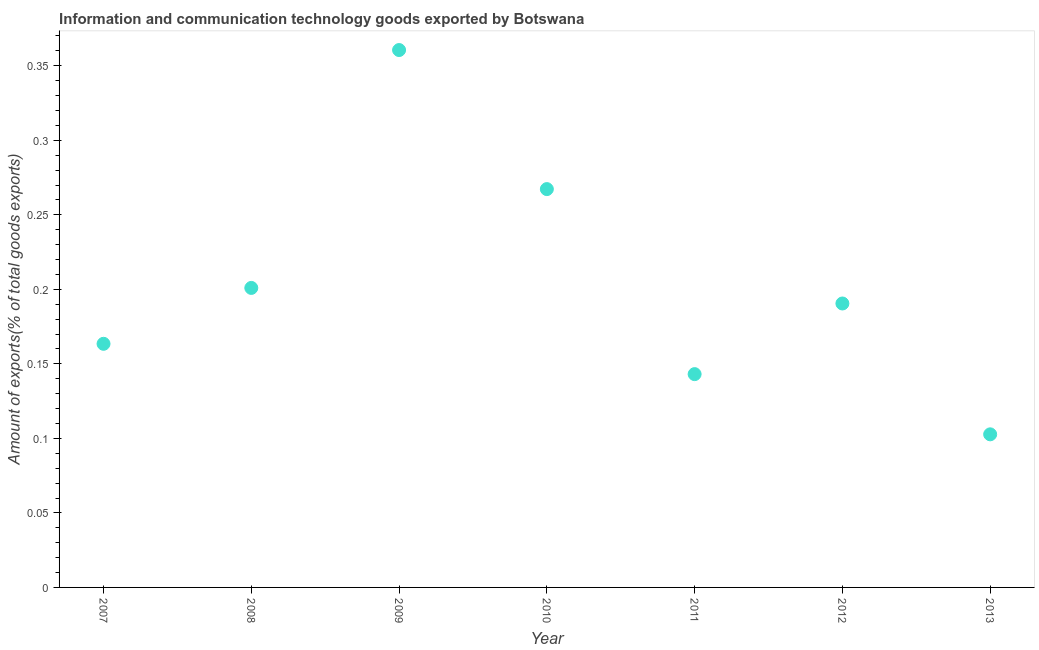What is the amount of ict goods exports in 2008?
Give a very brief answer. 0.2. Across all years, what is the maximum amount of ict goods exports?
Provide a succinct answer. 0.36. Across all years, what is the minimum amount of ict goods exports?
Your answer should be compact. 0.1. What is the sum of the amount of ict goods exports?
Offer a terse response. 1.43. What is the difference between the amount of ict goods exports in 2009 and 2011?
Give a very brief answer. 0.22. What is the average amount of ict goods exports per year?
Your answer should be compact. 0.2. What is the median amount of ict goods exports?
Your response must be concise. 0.19. Do a majority of the years between 2009 and 2007 (inclusive) have amount of ict goods exports greater than 0.22 %?
Give a very brief answer. No. What is the ratio of the amount of ict goods exports in 2010 to that in 2012?
Your response must be concise. 1.4. Is the amount of ict goods exports in 2007 less than that in 2012?
Give a very brief answer. Yes. What is the difference between the highest and the second highest amount of ict goods exports?
Ensure brevity in your answer.  0.09. Is the sum of the amount of ict goods exports in 2008 and 2011 greater than the maximum amount of ict goods exports across all years?
Your answer should be compact. No. What is the difference between the highest and the lowest amount of ict goods exports?
Your answer should be very brief. 0.26. Does the amount of ict goods exports monotonically increase over the years?
Offer a very short reply. No. How many years are there in the graph?
Your response must be concise. 7. Are the values on the major ticks of Y-axis written in scientific E-notation?
Give a very brief answer. No. What is the title of the graph?
Provide a short and direct response. Information and communication technology goods exported by Botswana. What is the label or title of the Y-axis?
Offer a very short reply. Amount of exports(% of total goods exports). What is the Amount of exports(% of total goods exports) in 2007?
Offer a terse response. 0.16. What is the Amount of exports(% of total goods exports) in 2008?
Offer a very short reply. 0.2. What is the Amount of exports(% of total goods exports) in 2009?
Provide a succinct answer. 0.36. What is the Amount of exports(% of total goods exports) in 2010?
Your answer should be very brief. 0.27. What is the Amount of exports(% of total goods exports) in 2011?
Provide a short and direct response. 0.14. What is the Amount of exports(% of total goods exports) in 2012?
Ensure brevity in your answer.  0.19. What is the Amount of exports(% of total goods exports) in 2013?
Keep it short and to the point. 0.1. What is the difference between the Amount of exports(% of total goods exports) in 2007 and 2008?
Provide a short and direct response. -0.04. What is the difference between the Amount of exports(% of total goods exports) in 2007 and 2009?
Make the answer very short. -0.2. What is the difference between the Amount of exports(% of total goods exports) in 2007 and 2010?
Offer a very short reply. -0.1. What is the difference between the Amount of exports(% of total goods exports) in 2007 and 2011?
Provide a short and direct response. 0.02. What is the difference between the Amount of exports(% of total goods exports) in 2007 and 2012?
Offer a very short reply. -0.03. What is the difference between the Amount of exports(% of total goods exports) in 2007 and 2013?
Your answer should be very brief. 0.06. What is the difference between the Amount of exports(% of total goods exports) in 2008 and 2009?
Provide a succinct answer. -0.16. What is the difference between the Amount of exports(% of total goods exports) in 2008 and 2010?
Offer a very short reply. -0.07. What is the difference between the Amount of exports(% of total goods exports) in 2008 and 2011?
Ensure brevity in your answer.  0.06. What is the difference between the Amount of exports(% of total goods exports) in 2008 and 2012?
Your response must be concise. 0.01. What is the difference between the Amount of exports(% of total goods exports) in 2008 and 2013?
Provide a short and direct response. 0.1. What is the difference between the Amount of exports(% of total goods exports) in 2009 and 2010?
Your answer should be very brief. 0.09. What is the difference between the Amount of exports(% of total goods exports) in 2009 and 2011?
Provide a succinct answer. 0.22. What is the difference between the Amount of exports(% of total goods exports) in 2009 and 2012?
Provide a short and direct response. 0.17. What is the difference between the Amount of exports(% of total goods exports) in 2009 and 2013?
Your answer should be very brief. 0.26. What is the difference between the Amount of exports(% of total goods exports) in 2010 and 2011?
Your answer should be compact. 0.12. What is the difference between the Amount of exports(% of total goods exports) in 2010 and 2012?
Make the answer very short. 0.08. What is the difference between the Amount of exports(% of total goods exports) in 2010 and 2013?
Provide a short and direct response. 0.16. What is the difference between the Amount of exports(% of total goods exports) in 2011 and 2012?
Offer a terse response. -0.05. What is the difference between the Amount of exports(% of total goods exports) in 2011 and 2013?
Offer a very short reply. 0.04. What is the difference between the Amount of exports(% of total goods exports) in 2012 and 2013?
Your answer should be very brief. 0.09. What is the ratio of the Amount of exports(% of total goods exports) in 2007 to that in 2008?
Your answer should be compact. 0.81. What is the ratio of the Amount of exports(% of total goods exports) in 2007 to that in 2009?
Your response must be concise. 0.45. What is the ratio of the Amount of exports(% of total goods exports) in 2007 to that in 2010?
Your answer should be compact. 0.61. What is the ratio of the Amount of exports(% of total goods exports) in 2007 to that in 2011?
Make the answer very short. 1.14. What is the ratio of the Amount of exports(% of total goods exports) in 2007 to that in 2012?
Provide a succinct answer. 0.86. What is the ratio of the Amount of exports(% of total goods exports) in 2007 to that in 2013?
Make the answer very short. 1.59. What is the ratio of the Amount of exports(% of total goods exports) in 2008 to that in 2009?
Make the answer very short. 0.56. What is the ratio of the Amount of exports(% of total goods exports) in 2008 to that in 2010?
Offer a very short reply. 0.75. What is the ratio of the Amount of exports(% of total goods exports) in 2008 to that in 2011?
Make the answer very short. 1.4. What is the ratio of the Amount of exports(% of total goods exports) in 2008 to that in 2012?
Provide a succinct answer. 1.05. What is the ratio of the Amount of exports(% of total goods exports) in 2008 to that in 2013?
Make the answer very short. 1.96. What is the ratio of the Amount of exports(% of total goods exports) in 2009 to that in 2010?
Your response must be concise. 1.35. What is the ratio of the Amount of exports(% of total goods exports) in 2009 to that in 2011?
Your answer should be compact. 2.52. What is the ratio of the Amount of exports(% of total goods exports) in 2009 to that in 2012?
Your response must be concise. 1.89. What is the ratio of the Amount of exports(% of total goods exports) in 2009 to that in 2013?
Provide a short and direct response. 3.51. What is the ratio of the Amount of exports(% of total goods exports) in 2010 to that in 2011?
Offer a terse response. 1.87. What is the ratio of the Amount of exports(% of total goods exports) in 2010 to that in 2012?
Ensure brevity in your answer.  1.4. What is the ratio of the Amount of exports(% of total goods exports) in 2010 to that in 2013?
Offer a terse response. 2.6. What is the ratio of the Amount of exports(% of total goods exports) in 2011 to that in 2012?
Your answer should be compact. 0.75. What is the ratio of the Amount of exports(% of total goods exports) in 2011 to that in 2013?
Provide a short and direct response. 1.39. What is the ratio of the Amount of exports(% of total goods exports) in 2012 to that in 2013?
Provide a succinct answer. 1.85. 